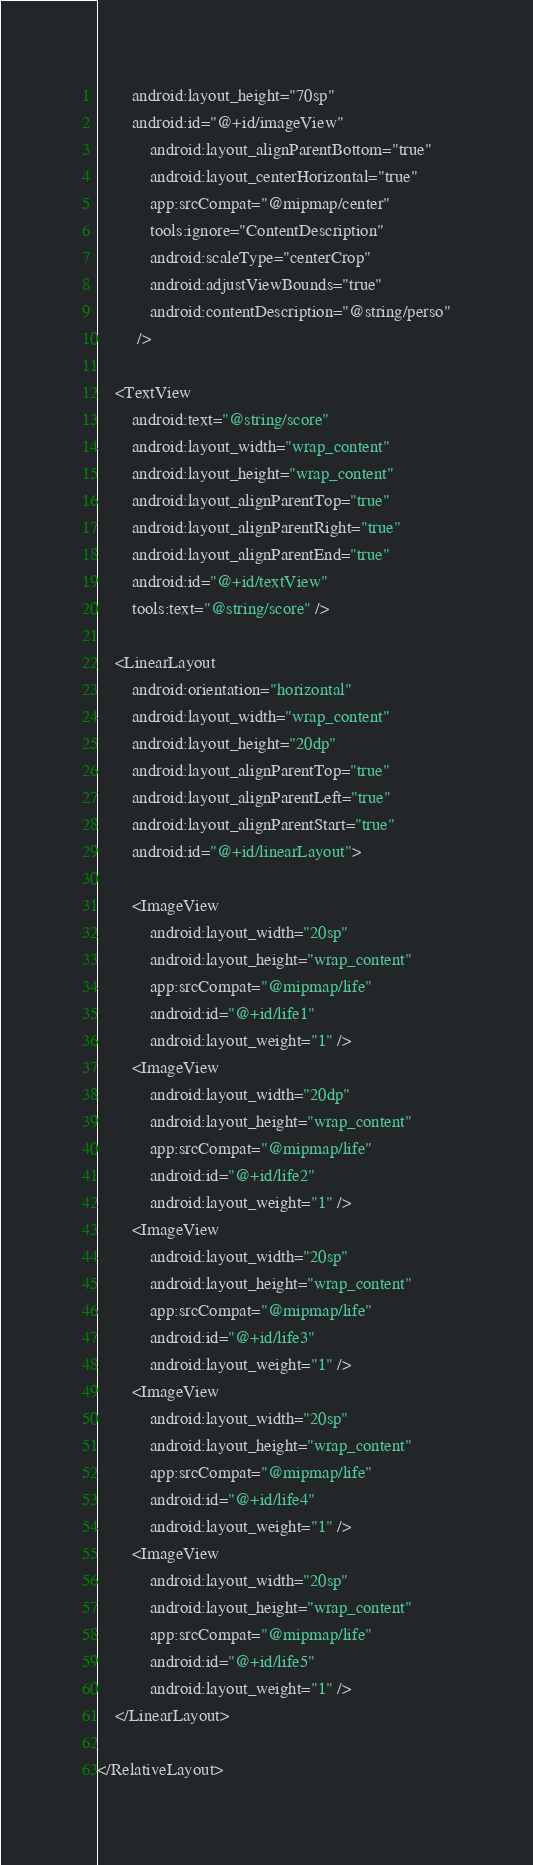Convert code to text. <code><loc_0><loc_0><loc_500><loc_500><_XML_>        android:layout_height="70sp"
        android:id="@+id/imageView"
            android:layout_alignParentBottom="true"
            android:layout_centerHorizontal="true"
            app:srcCompat="@mipmap/center"
            tools:ignore="ContentDescription"
            android:scaleType="centerCrop"
            android:adjustViewBounds="true"
            android:contentDescription="@string/perso"
         />

    <TextView
        android:text="@string/score"
        android:layout_width="wrap_content"
        android:layout_height="wrap_content"
        android:layout_alignParentTop="true"
        android:layout_alignParentRight="true"
        android:layout_alignParentEnd="true"
        android:id="@+id/textView"
        tools:text="@string/score" />

    <LinearLayout
        android:orientation="horizontal"
        android:layout_width="wrap_content"
        android:layout_height="20dp"
        android:layout_alignParentTop="true"
        android:layout_alignParentLeft="true"
        android:layout_alignParentStart="true"
        android:id="@+id/linearLayout">

        <ImageView
            android:layout_width="20sp"
            android:layout_height="wrap_content"
            app:srcCompat="@mipmap/life"
            android:id="@+id/life1"
            android:layout_weight="1" />
        <ImageView
            android:layout_width="20dp"
            android:layout_height="wrap_content"
            app:srcCompat="@mipmap/life"
            android:id="@+id/life2"
            android:layout_weight="1" />
        <ImageView
            android:layout_width="20sp"
            android:layout_height="wrap_content"
            app:srcCompat="@mipmap/life"
            android:id="@+id/life3"
            android:layout_weight="1" />
        <ImageView
            android:layout_width="20sp"
            android:layout_height="wrap_content"
            app:srcCompat="@mipmap/life"
            android:id="@+id/life4"
            android:layout_weight="1" />
        <ImageView
            android:layout_width="20sp"
            android:layout_height="wrap_content"
            app:srcCompat="@mipmap/life"
            android:id="@+id/life5"
            android:layout_weight="1" />
    </LinearLayout>

</RelativeLayout></code> 